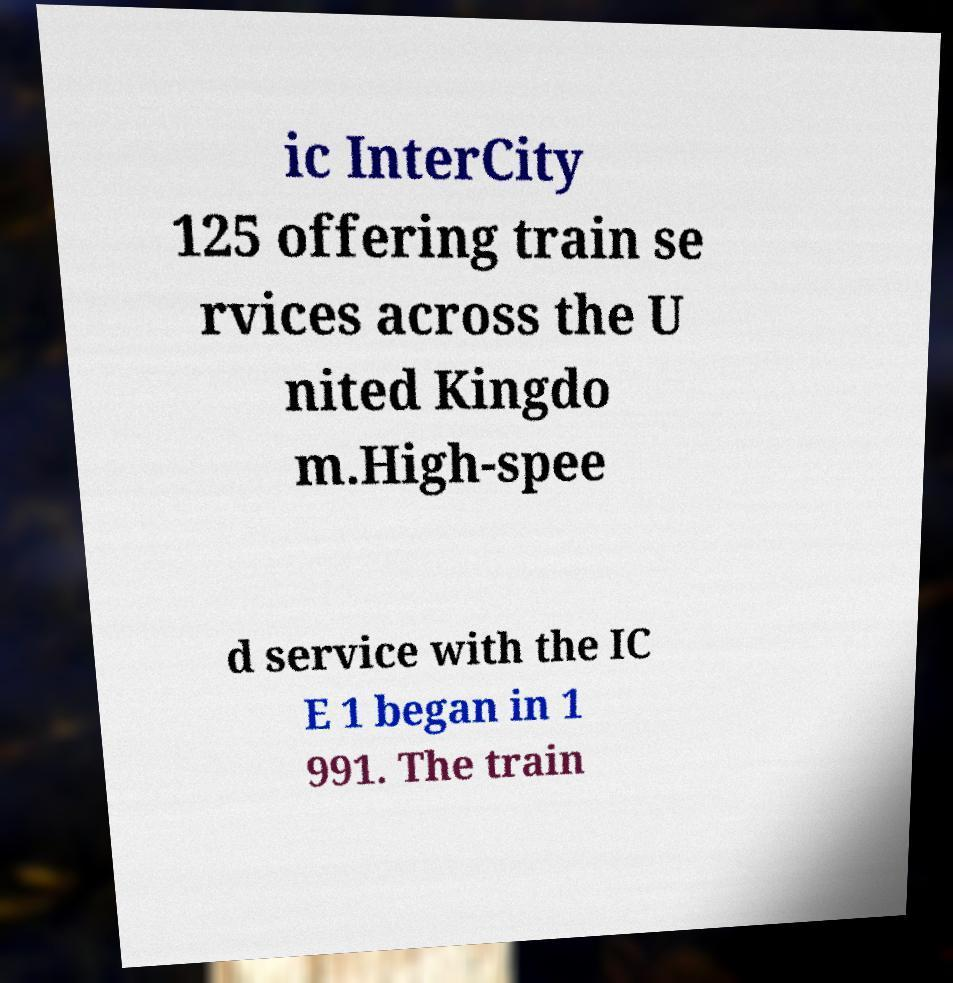Can you read and provide the text displayed in the image?This photo seems to have some interesting text. Can you extract and type it out for me? ic InterCity 125 offering train se rvices across the U nited Kingdo m.High-spee d service with the IC E 1 began in 1 991. The train 